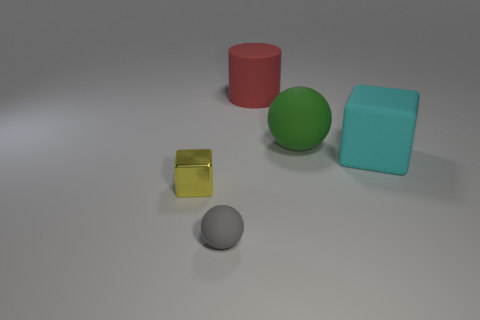There is a block that is to the left of the big green matte ball; what size is it?
Offer a very short reply. Small. How many big cyan things are on the right side of the block on the left side of the cube right of the small yellow metal cube?
Offer a very short reply. 1. Is the big matte block the same color as the tiny matte sphere?
Ensure brevity in your answer.  No. What number of objects are to the left of the small gray rubber object and on the right side of the matte cylinder?
Give a very brief answer. 0. There is a big object that is to the right of the large green matte object; what shape is it?
Offer a very short reply. Cube. Is the number of large rubber objects that are behind the red cylinder less than the number of tiny objects behind the large cyan rubber block?
Ensure brevity in your answer.  No. Is the sphere that is behind the small metal thing made of the same material as the sphere that is left of the large red thing?
Make the answer very short. Yes. What shape is the big cyan matte object?
Your answer should be compact. Cube. Is the number of tiny yellow metallic cubes behind the big green ball greater than the number of large objects that are to the right of the big cyan object?
Make the answer very short. No. Does the rubber thing that is in front of the rubber block have the same shape as the small yellow shiny object in front of the red thing?
Keep it short and to the point. No. 